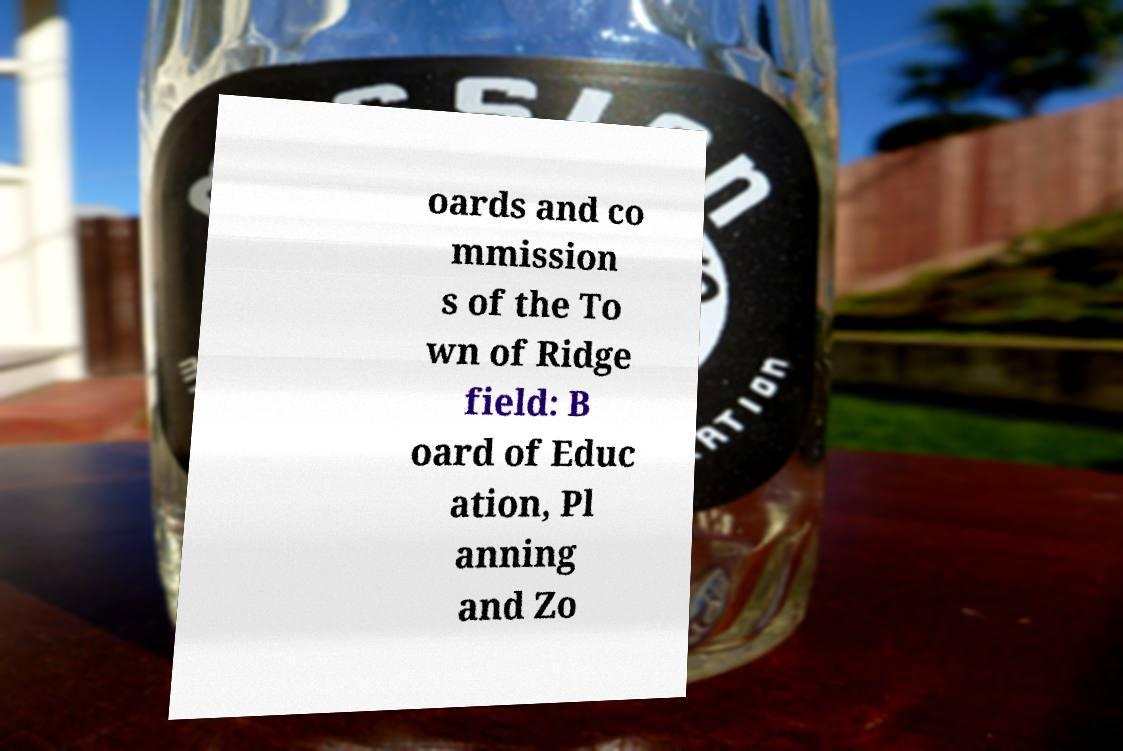What messages or text are displayed in this image? I need them in a readable, typed format. oards and co mmission s of the To wn of Ridge field: B oard of Educ ation, Pl anning and Zo 